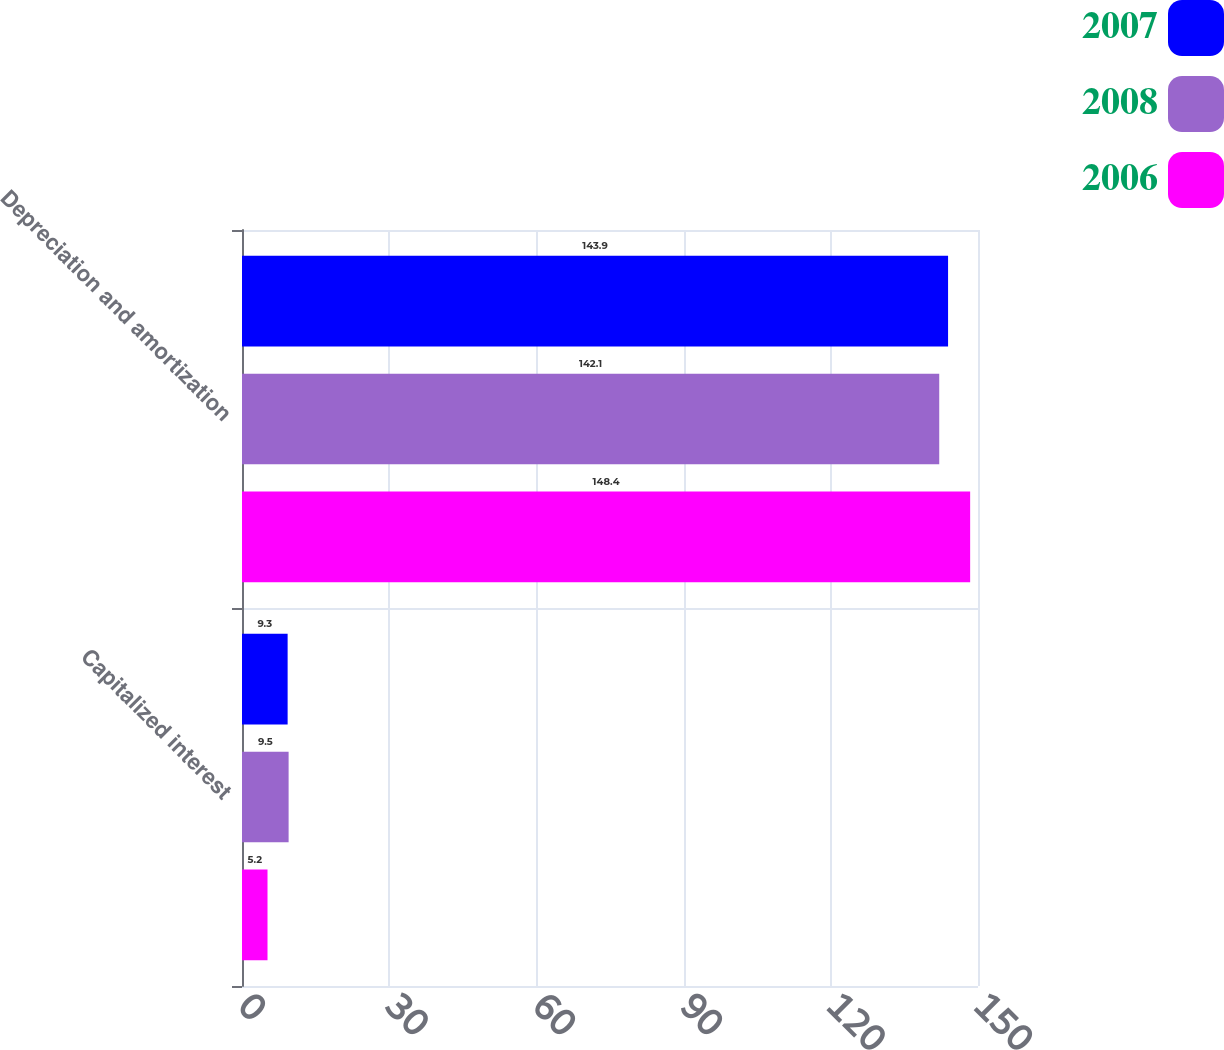<chart> <loc_0><loc_0><loc_500><loc_500><stacked_bar_chart><ecel><fcel>Capitalized interest<fcel>Depreciation and amortization<nl><fcel>2007<fcel>9.3<fcel>143.9<nl><fcel>2008<fcel>9.5<fcel>142.1<nl><fcel>2006<fcel>5.2<fcel>148.4<nl></chart> 